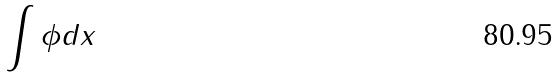Convert formula to latex. <formula><loc_0><loc_0><loc_500><loc_500>\int \phi d x</formula> 